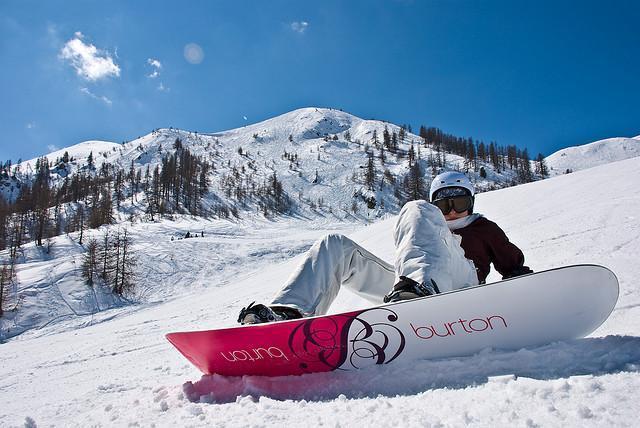Who crafted the thing on the person's feet?
From the following four choices, select the correct answer to address the question.
Options: Company, shoe maker, hobbyist, jeweler. Company. 